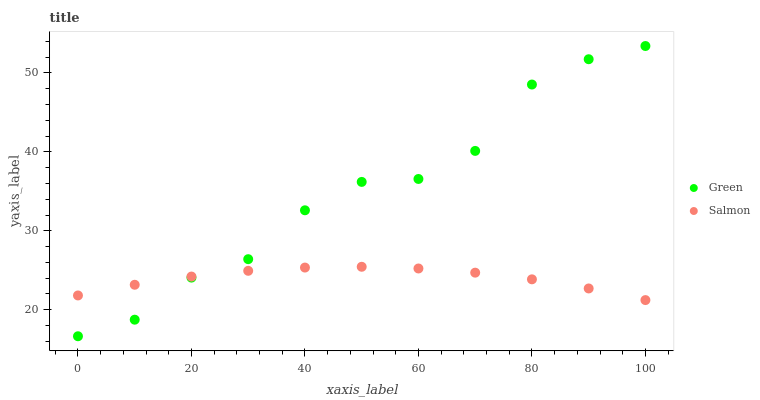Does Salmon have the minimum area under the curve?
Answer yes or no. Yes. Does Green have the maximum area under the curve?
Answer yes or no. Yes. Does Green have the minimum area under the curve?
Answer yes or no. No. Is Salmon the smoothest?
Answer yes or no. Yes. Is Green the roughest?
Answer yes or no. Yes. Is Green the smoothest?
Answer yes or no. No. Does Green have the lowest value?
Answer yes or no. Yes. Does Green have the highest value?
Answer yes or no. Yes. Does Salmon intersect Green?
Answer yes or no. Yes. Is Salmon less than Green?
Answer yes or no. No. Is Salmon greater than Green?
Answer yes or no. No. 